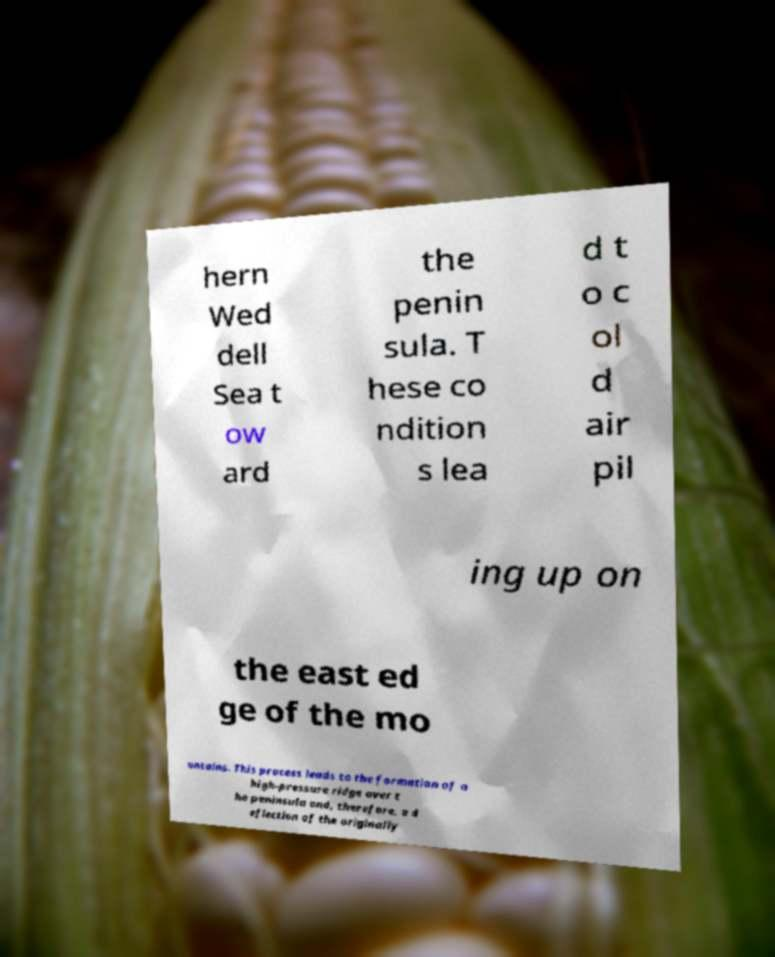For documentation purposes, I need the text within this image transcribed. Could you provide that? hern Wed dell Sea t ow ard the penin sula. T hese co ndition s lea d t o c ol d air pil ing up on the east ed ge of the mo untains. This process leads to the formation of a high-pressure ridge over t he peninsula and, therefore, a d eflection of the originally 